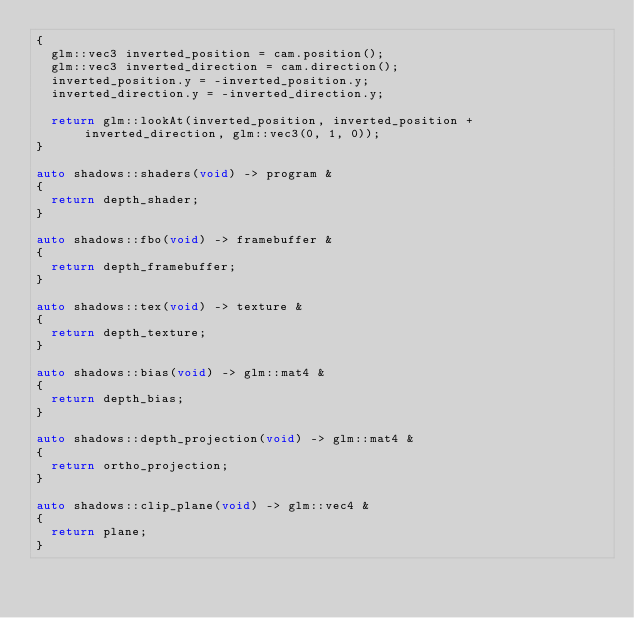Convert code to text. <code><loc_0><loc_0><loc_500><loc_500><_C++_>{
	glm::vec3 inverted_position = cam.position();
	glm::vec3 inverted_direction = cam.direction();
	inverted_position.y = -inverted_position.y;
	inverted_direction.y = -inverted_direction.y;

	return glm::lookAt(inverted_position, inverted_position + inverted_direction, glm::vec3(0, 1, 0));
}

auto shadows::shaders(void) -> program &
{
	return depth_shader;
}

auto shadows::fbo(void) -> framebuffer &
{
	return depth_framebuffer;
}

auto shadows::tex(void) -> texture &
{
	return depth_texture;
}

auto shadows::bias(void) -> glm::mat4 &
{
	return depth_bias;
}

auto shadows::depth_projection(void) -> glm::mat4 &
{
	return ortho_projection;
}

auto shadows::clip_plane(void) -> glm::vec4 &
{
	return plane;
}</code> 